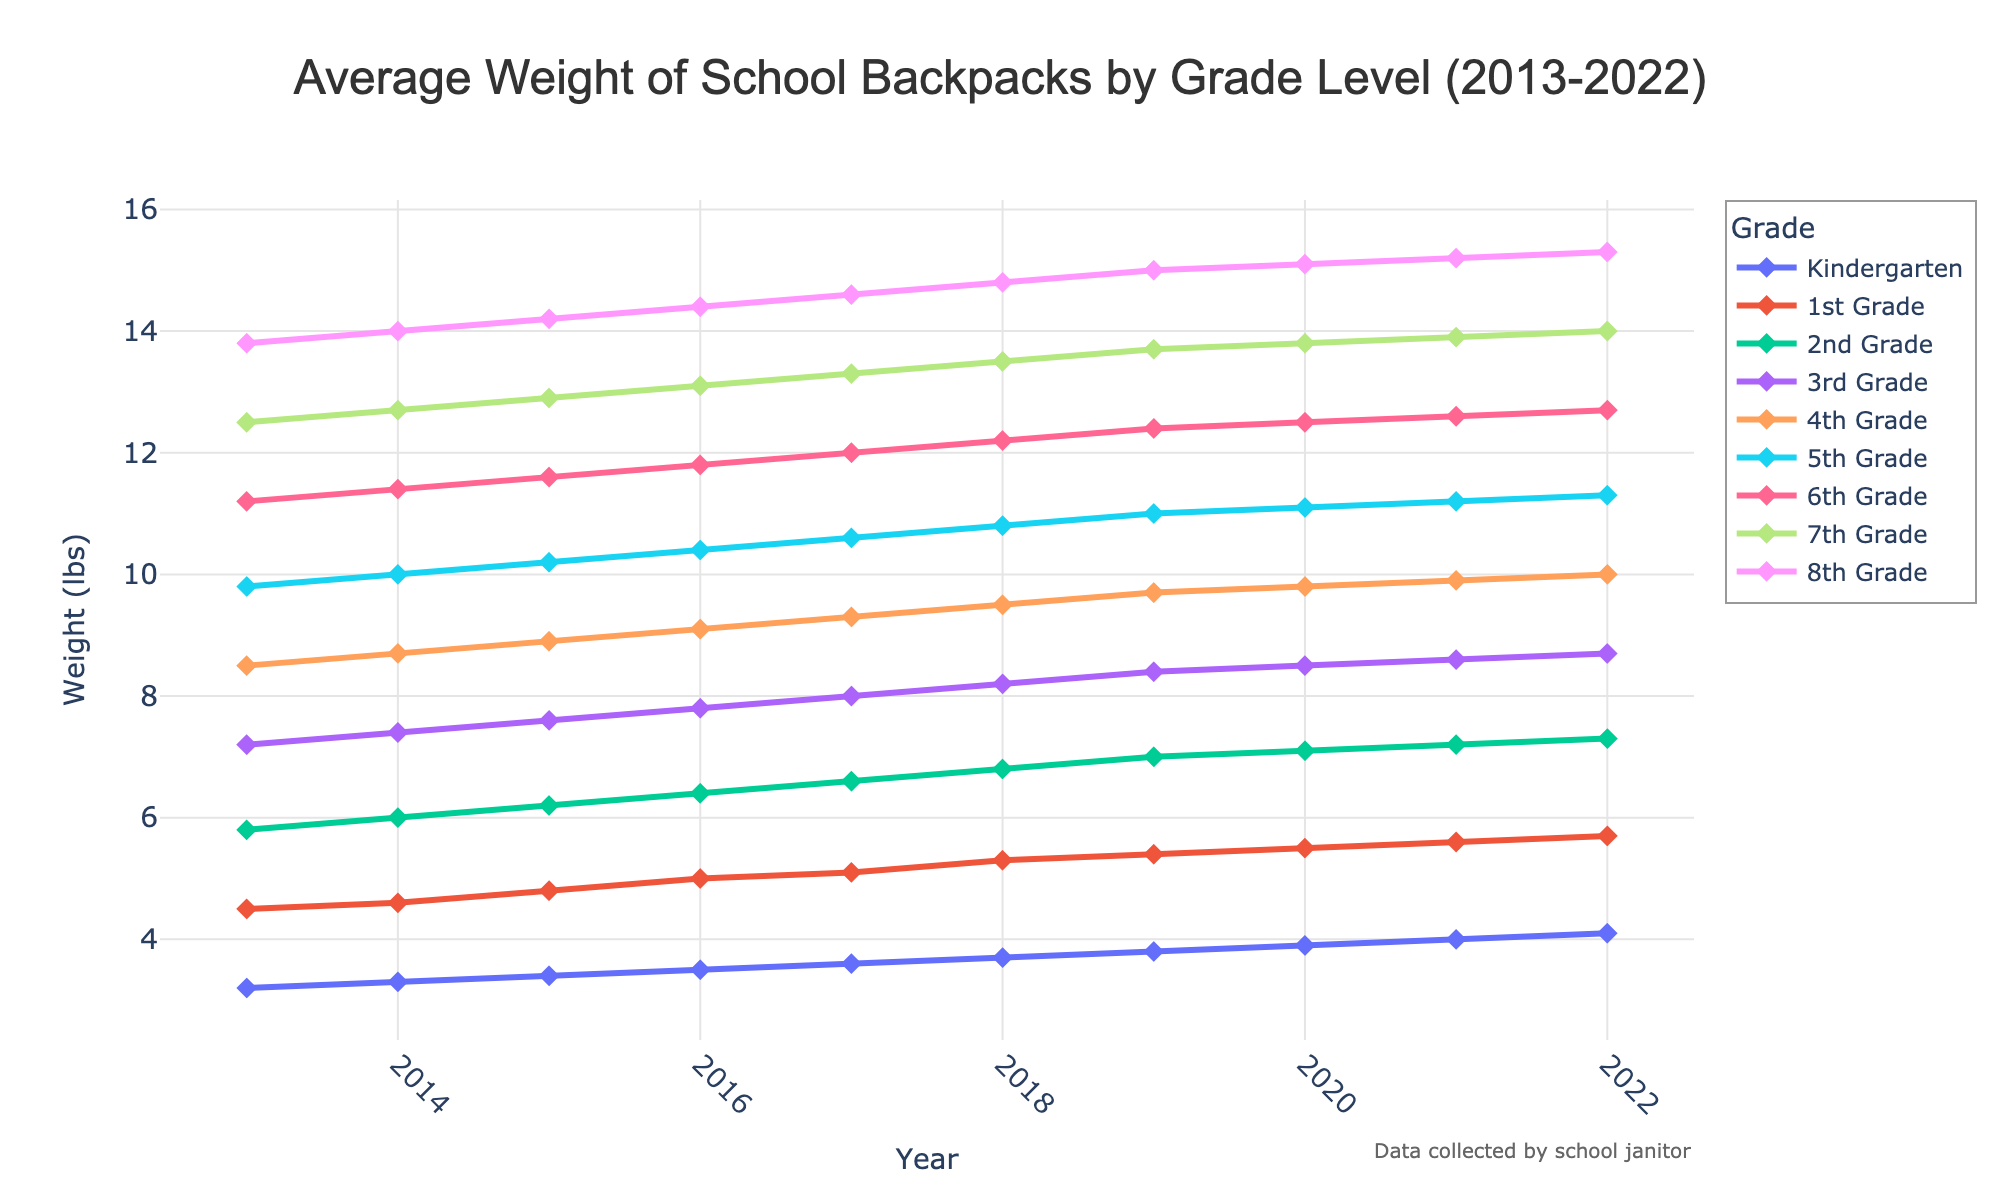What's the average weight of backpacks for 4th grade students from 2013 to 2022? To find the average weight, sum the weights for each year from 2013 to 2022 and divide by the number of years. The weights are 8.5, 8.7, 8.9, 9.1, 9.3, 9.5, 9.7, 9.8, 9.9, and 10.0. The sum is 93.4, and there are 10 data points. So, the average is 93.4/10 = 9.34.
Answer: 9.34 Which grade level had the heaviest average backpack weight in 2022? To answer this, look at the weights for each grade level in 2022. The weights are Kindergarten: 4.1, 1st Grade: 5.7, 2nd Grade: 7.3, 3rd Grade: 8.7, 4th Grade: 10.0, 5th Grade: 11.3, 6th Grade: 12.7, 7th Grade: 14.0, and 8th Grade: 15.3. The heaviest backpack weight is for 8th Grade at 15.3 lbs.
Answer: 8th Grade By how much did the average weight of 1st grade backpacks increase from 2013 to 2022? Subtract the weight of 1st grade backpacks in 2013 from the weight in 2022. The weights are 4.5 in 2013 and 5.7 in 2022. The increase is 5.7 - 4.5 = 1.2 lbs.
Answer: 1.2 lbs Which grade had the smallest relative increase in backpack weight over the decade? To find the smallest relative increase, calculate the increase for each grade and then divide by the initial weight in 2013. The relative increases are Kindergarten: (4.1-3.2)/3.2=0.281, 1st Grade: (5.7-4.5)/4.5=0.267, 2nd Grade: (7.3-5.8)/5.8=0.259, 3rd Grade: (8.7-7.2)/7.2=0.208, 4th Grade: (10.0-8.5)/8.5=0.176, 5th Grade: (11.3-9.8)/9.8=0.153, 6th Grade: (12.7-11.2)/11.2=0.134, 7th Grade: (14.0-12.5)/12.5=0.120, 8th Grade: (15.3-13.8)/13.8=0.109. The smallest relative increase is for 8th Grade at approximately 10.9%.
Answer: 8th Grade In which year did the average weight of 2nd grade backpacks first exceed 6 lbs? Look at the weight of backpacks for 2nd Grade over the years. The weights are: 2013: 5.8, 2014: 6.0, 2015: 6.2, etc. The 2nd grade backpacks first exceeded 6 lbs in 2014.
Answer: 2014 Is the increase in backpack weight consistent across all grades over the decade? Check the trend lines for each grade. All grades show a consistent upward trend in the weights of backpacks from 2013 to 2022.
Answer: Yes What is the difference in average backpack weight between 3rd Grade and 5th Grade in 2021? Subtract the weight of 3rd Grade backpacks in 2021 from the weight of 5th Grade backpacks in 2021. The weights are 3rd Grade: 8.6 and 5th Grade: 11.2. The difference is 11.2 - 8.6 = 2.6 lbs.
Answer: 2.6 lbs 